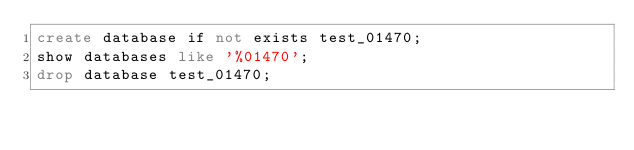Convert code to text. <code><loc_0><loc_0><loc_500><loc_500><_SQL_>create database if not exists test_01470;
show databases like '%01470';
drop database test_01470;
</code> 